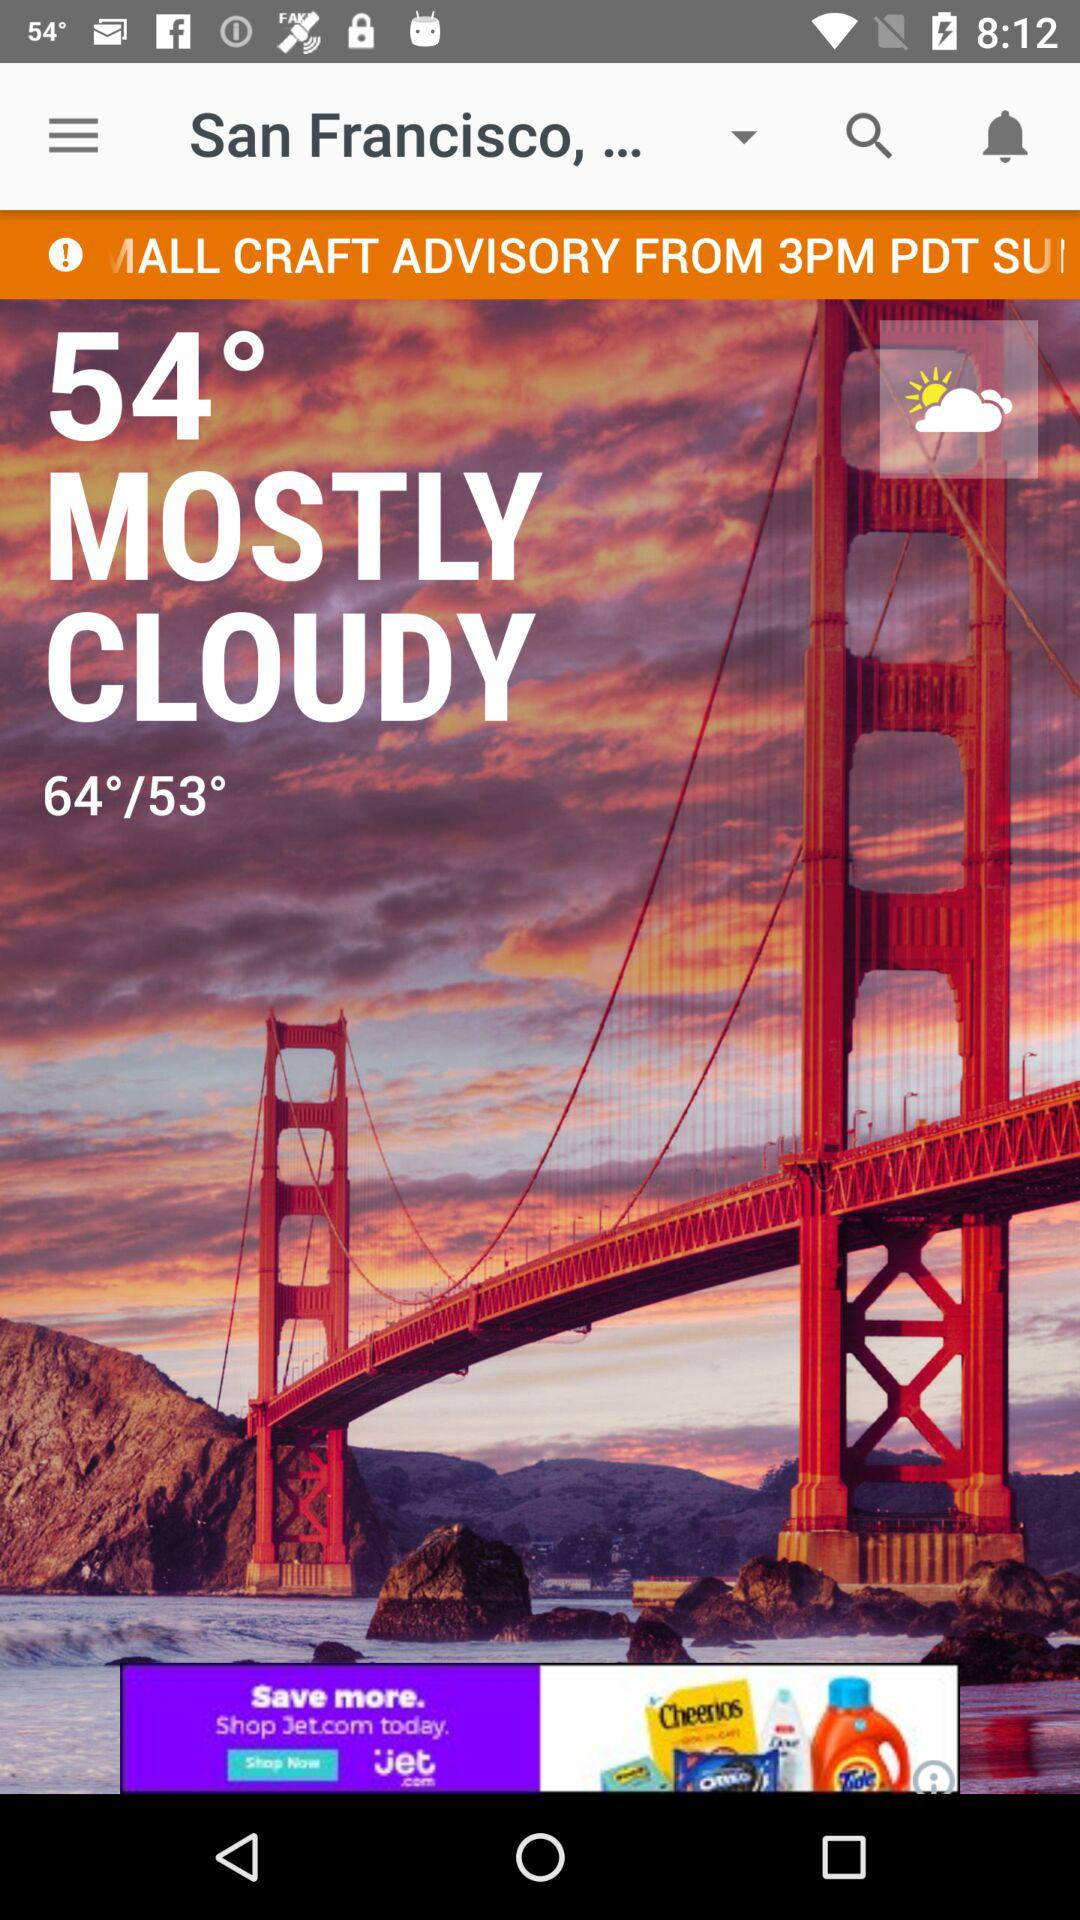How many degrees warmer is the high temperature than the low temperature?
Answer the question using a single word or phrase. 11 